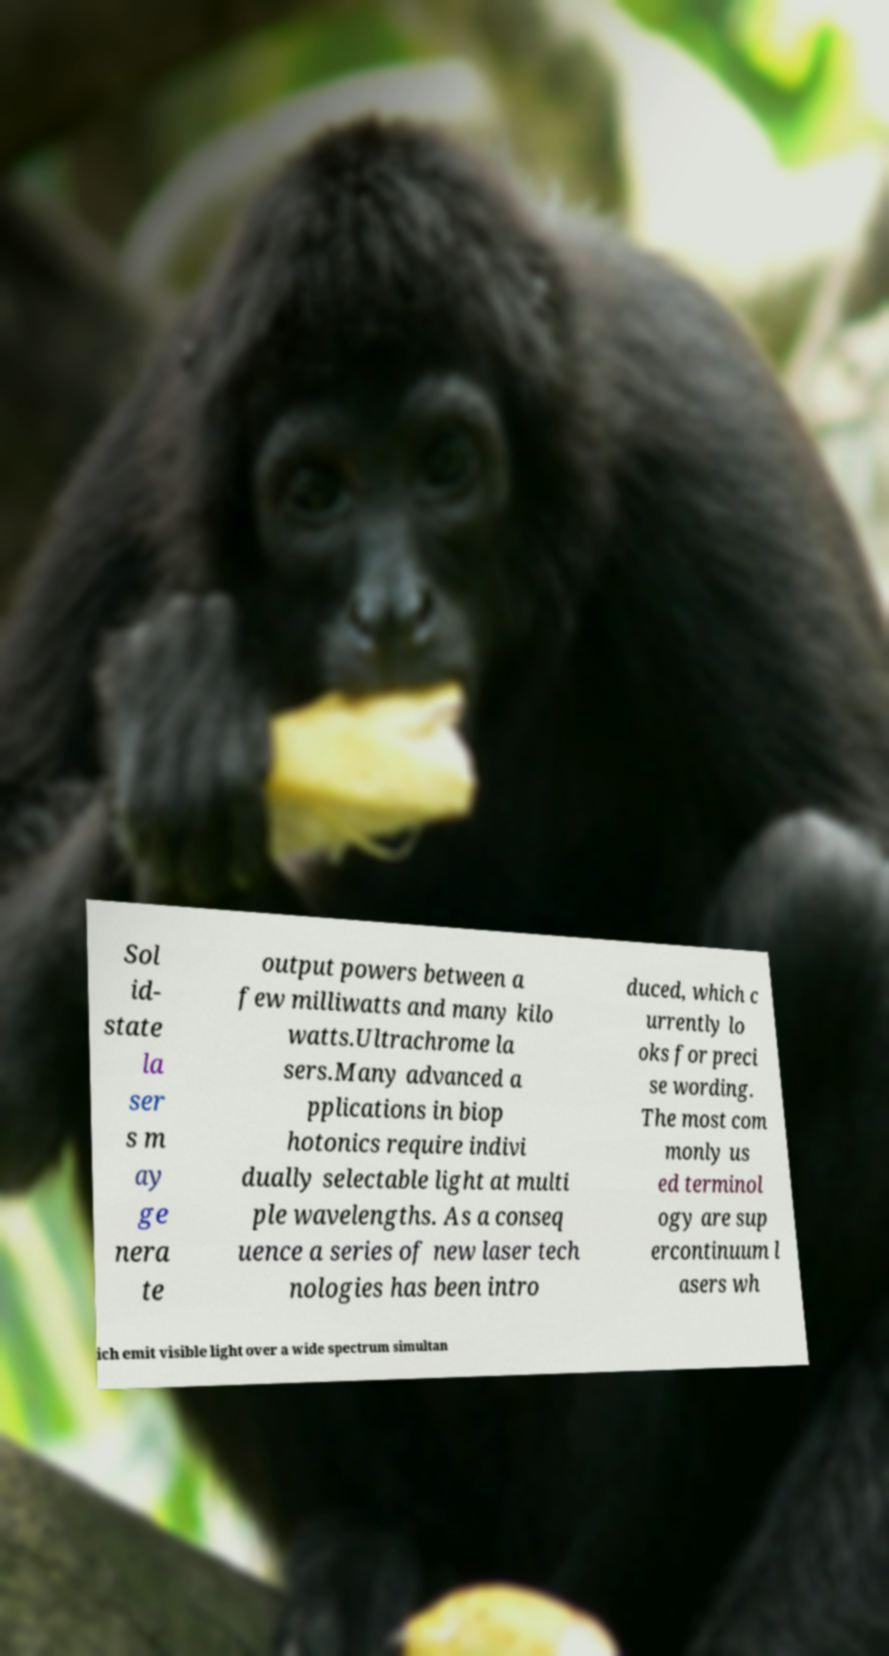Can you accurately transcribe the text from the provided image for me? Sol id- state la ser s m ay ge nera te output powers between a few milliwatts and many kilo watts.Ultrachrome la sers.Many advanced a pplications in biop hotonics require indivi dually selectable light at multi ple wavelengths. As a conseq uence a series of new laser tech nologies has been intro duced, which c urrently lo oks for preci se wording. The most com monly us ed terminol ogy are sup ercontinuum l asers wh ich emit visible light over a wide spectrum simultan 